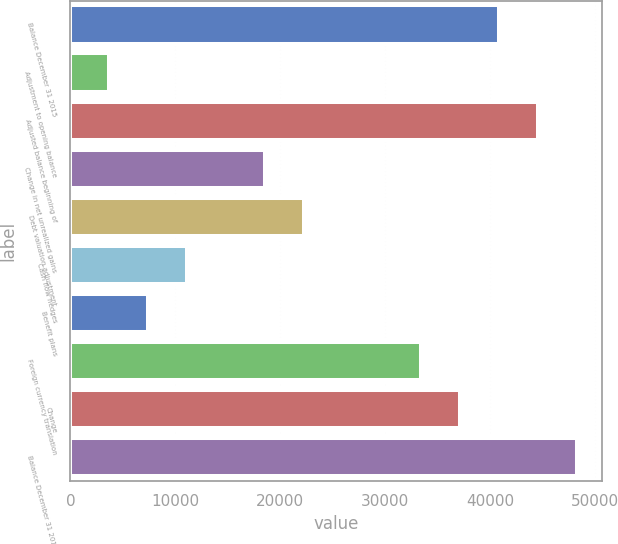Convert chart to OTSL. <chart><loc_0><loc_0><loc_500><loc_500><bar_chart><fcel>Balance December 31 2015<fcel>Adjustment to opening balance<fcel>Adjusted balance beginning of<fcel>Change in net unrealized gains<fcel>Debt valuation adjustment<fcel>Cash flow hedges<fcel>Benefit plans<fcel>Foreign currency translation<fcel>Change<fcel>Balance December 31 2016<nl><fcel>40886.7<fcel>3719.7<fcel>44603.4<fcel>18586.5<fcel>22303.2<fcel>11153.1<fcel>7436.4<fcel>33453.3<fcel>37170<fcel>48320.1<nl></chart> 